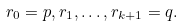<formula> <loc_0><loc_0><loc_500><loc_500>r _ { 0 } = p , r _ { 1 } , \dots , r _ { k + 1 } = q .</formula> 